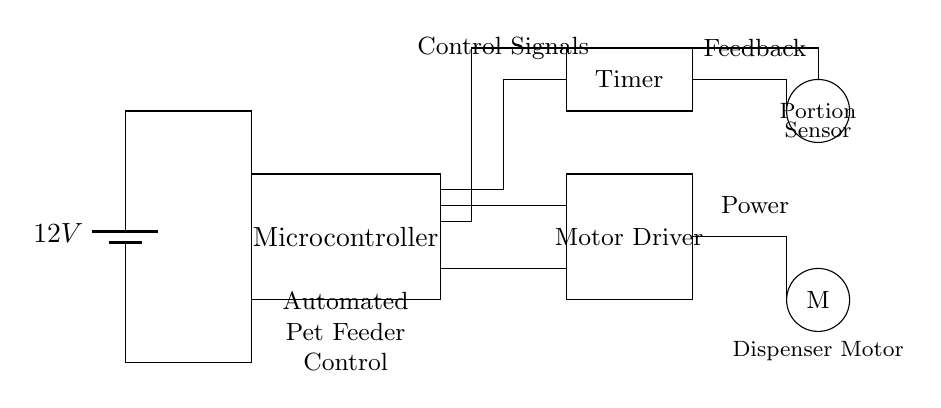What is the power supply voltage? The circuit shows a battery labeled with a potential of 12V, indicating that this is the voltage supplied to the circuit components.
Answer: 12V What component receives control signals? The diagram labels a specific section as "Control Signals" near the microcontroller, indicating that this component processes control inputs to manage the pet feeder's operation.
Answer: Microcontroller What does the portion sensor do? The diagram presents a component labeled as "Portion Sensor," which is likely responsible for detecting the amount of food dispensed, providing feedback to ensure appropriate servings are given to pets.
Answer: Detects food portion How is the motor connected to the power supply? The diagram shows a direct connection from the battery to the motor driver; this indicates that the motor will receive power through the driver when activated by the control signals.
Answer: Through motor driver How many main types of components are shown in the circuit? The circuit consists of five main components: a power supply, microcontroller, timer, motor driver, and portion sensor, indicating a well-structured automated control system.
Answer: Five What is the function of the timer in this circuit? The diagram shows a component labeled "Timer," which is usually responsible for controlling the duration of operations, ensuring that the automated feeder dispenses food at scheduled intervals.
Answer: Controls feeding schedule Which component provides feedback to the microcontroller? The portion sensor sends feedback regarding the amount of food dispensed back to the microcontroller, allowing it to adjust the portions based on the input received.
Answer: Portion sensor 